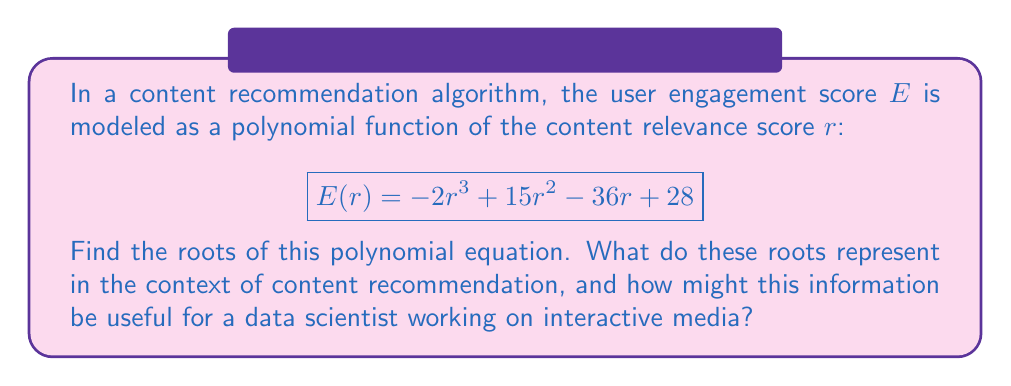Teach me how to tackle this problem. To find the roots of the polynomial equation, we need to solve $E(r) = 0$:

$$-2r^3 + 15r^2 - 36r + 28 = 0$$

Let's approach this step-by-step:

1) First, we can factor out the greatest common factor:
   $$-1(2r^3 - 15r^2 + 36r - 28) = 0$$

2) Now, let's try to guess one root. We can see that $r = 2$ is a solution:
   $$-1(2(2)^3 - 15(2)^2 + 36(2) - 28) = -1(16 - 60 + 72 - 28) = -1(0) = 0$$

3) So $(r - 2)$ is a factor. We can use polynomial long division to find the other factor:

   $$\frac{2r^3 - 15r^2 + 36r - 28}{r - 2} = 2r^2 - 11r + 14$$

4) Therefore, our equation becomes:
   $$-1(r - 2)(2r^2 - 11r + 14) = 0$$

5) We can factor the quadratic term further:
   $$-1(r - 2)(2r - 7)(r - 2) = 0$$

6) Solving for $r$, we get:
   $$r = 2, \quad r = 2, \quad r = \frac{7}{2}$$

In the context of content recommendation:
- These roots represent the relevance scores at which the engagement score is zero.
- The double root at $r = 2$ suggests a turning point in the engagement function.
- The root at $r = \frac{7}{2}$ represents another point where engagement crosses zero.

For a data scientist working on interactive media, this information could be valuable for:
1. Understanding the relationship between content relevance and user engagement.
2. Identifying optimal relevance scores for maximizing engagement.
3. Detecting potential issues in the recommendation algorithm, such as why engagement might be zero for relatively high relevance scores.
4. Calibrating the relevance scoring system to better align with actual user engagement.
Answer: The roots of the polynomial equation are $r = 2$ (double root) and $r = \frac{7}{2}$. 